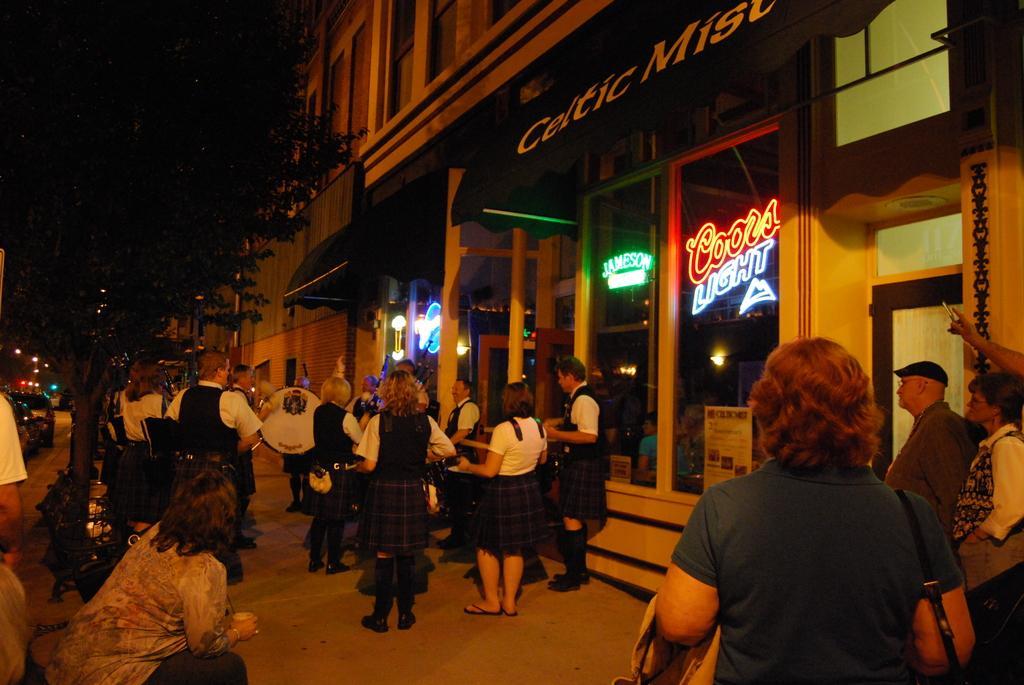Describe this image in one or two sentences. In this picture I can see group of people standing, there are few people holding musical instruments, there are buildings, light boards, lights, there is a tree, there are vehicles parked on the road. 